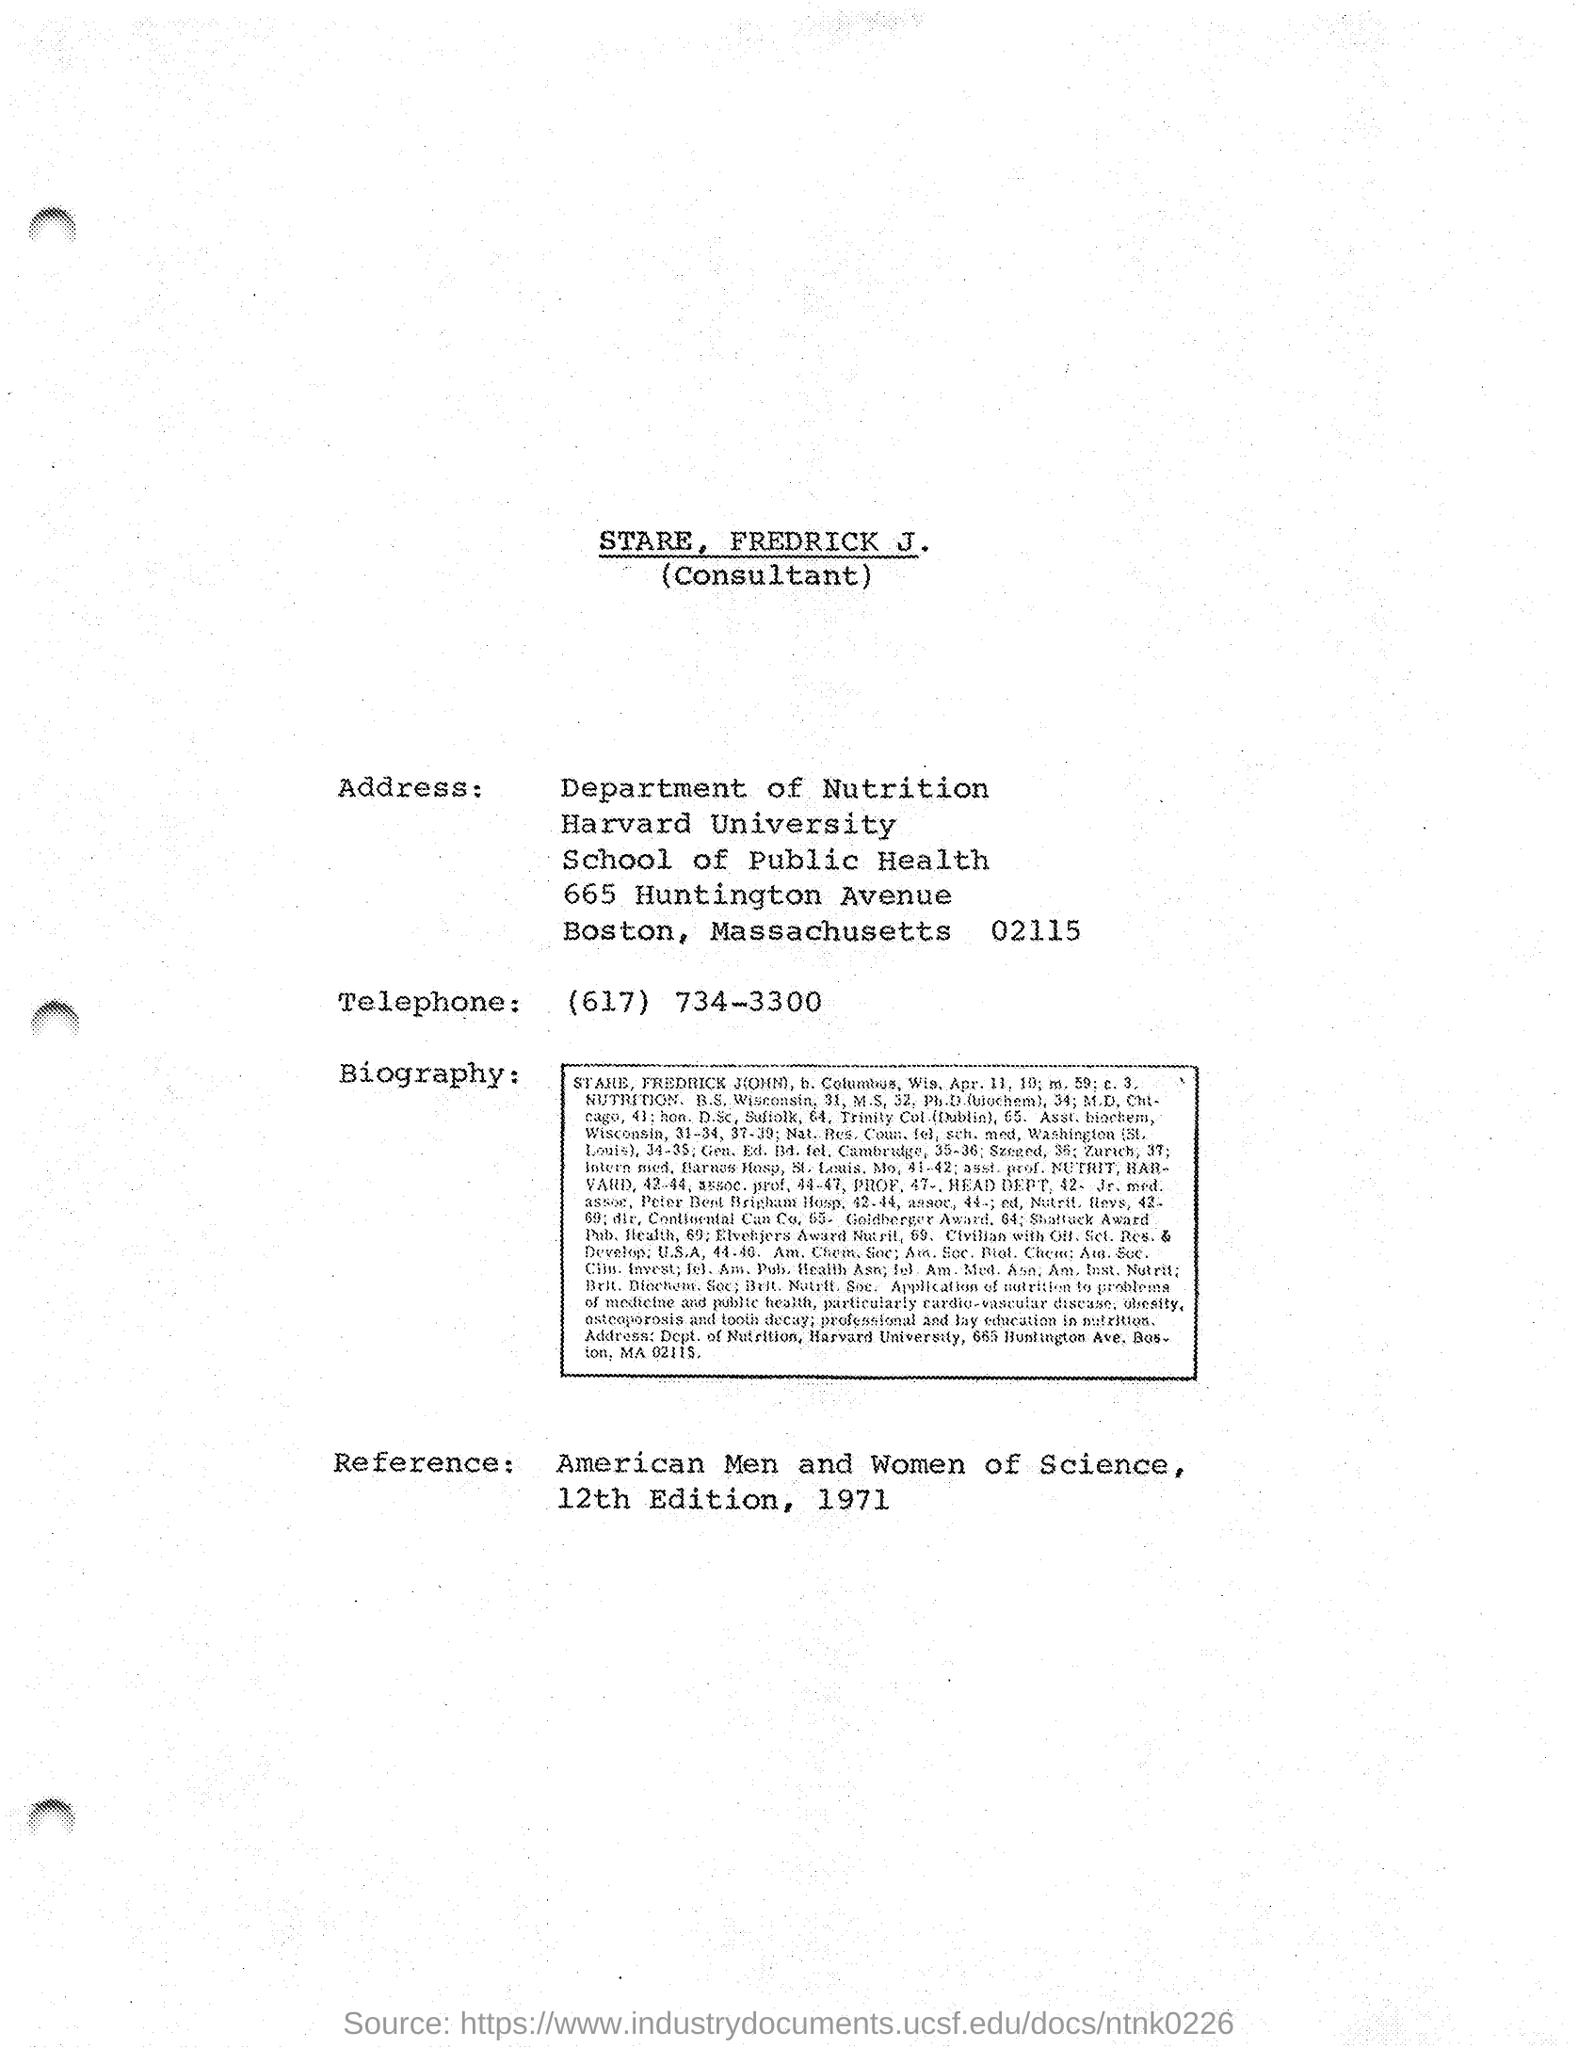Which department does stare belongs to?
Ensure brevity in your answer.  Department of Nutrition. 